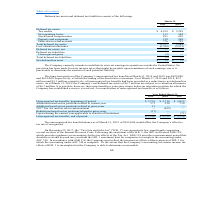From Gsi Technology's financial document, What was the long term portion of the unrecognized tax benefits in 2019 and 2018 respectively? The document shows two values: $622,000 and $619,000. From the document: "and $619,000, respectively, of which the timing of the resolution is uncertain. As of March 31, 2019 and 2018, $ gnized tax benefits at March 31, 2019..." Also, What was the net deferred tax assets in 2019? According to the financial document, $6.7 million. The relevant text states: "31, 2019, the Company’s net deferred tax assets of $6.7 million are subject to a valuation allowance of $6.7 million. It is possible, however, that some months or y 31, 2019, the Company’s net deferre..." Also, What was the Unrecognized tax benefits, beginning of period in 2019? According to the financial document, $2,735 (in thousands). The relevant text states: "Unrecognized tax benefits, beginning of period $ 2,735 $ 2,714 $ 2,055..." Additionally, In which year was Additions based on tax positions related to current year less than 600 thousands? The document shows two values: 2019 and 2018. Locate and analyze additions based on tax positions related to current year in row 5. From the document: "2019 2018 2017 2019 2018 2017..." Also, can you calculate: What is the average Additions based on tax positions related to prior years between 2017-2019? To answer this question, I need to perform calculations using the financial data. The calculation is: (13 + 0 + 0) / 3, which equals 4.33 (in thousands). This is based on the information: "2019 2018 2017 ons based on tax positions related to prior years 13 — —..." The key data points involved are: 0, 13. Also, can you calculate: What was the change in the Unrecognized tax benefits, end of period from 2018 to 2019? Based on the calculation: 3,102 - 2,735, the result is 367 (in thousands). This is based on the information: "Unrecognized tax benefits, beginning of period $ 2,735 $ 2,714 $ 2,055 Unrecognized tax benefits, end of period $ 3,102 $ 2,735 $ 2,714..." The key data points involved are: 2,735, 3,102. 